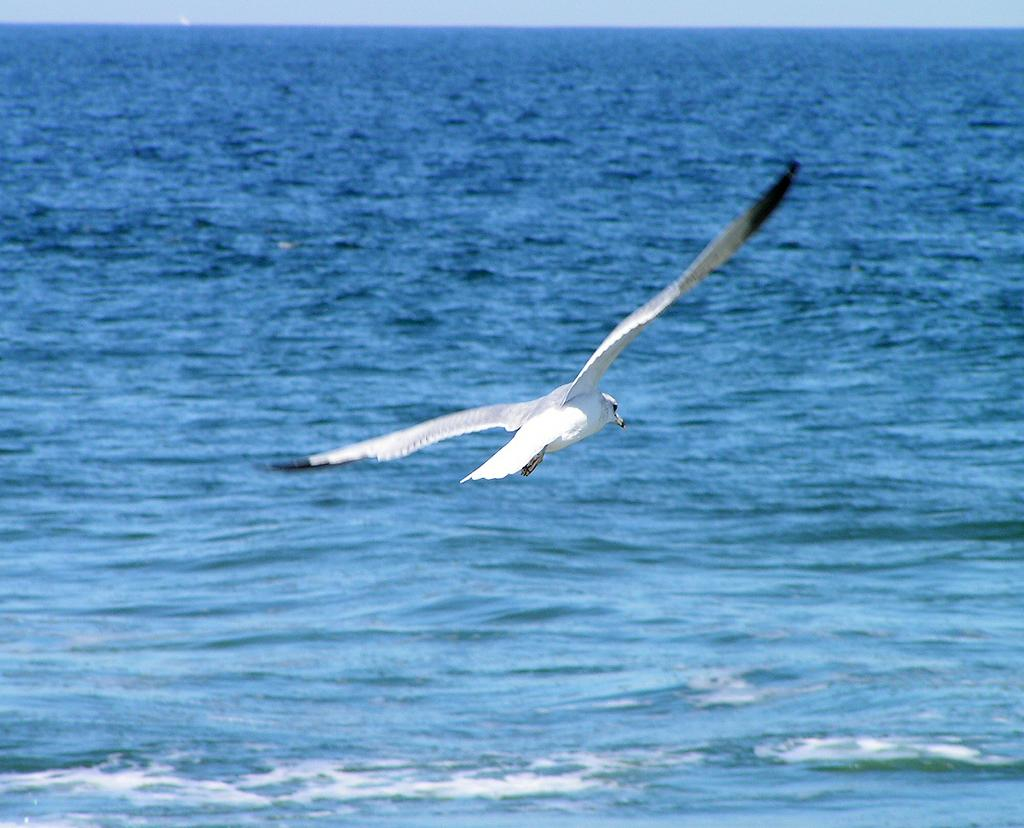What is the main subject of the image? There is a bird flying in the air in the image. What can be seen below the bird in the image? There is water visible in the image. What is visible at the top of the image? The sky is visible at the top of the image. What is the bird's desire while flying in the image? There is no information about the bird's desires in the image, so it cannot be determined. 